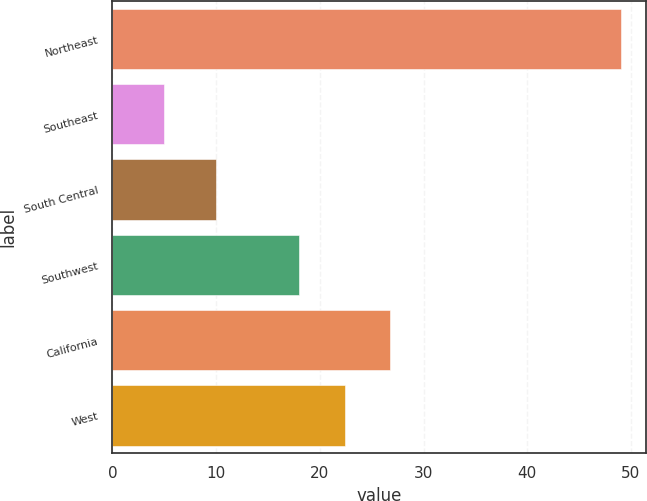Convert chart. <chart><loc_0><loc_0><loc_500><loc_500><bar_chart><fcel>Northeast<fcel>Southeast<fcel>South Central<fcel>Southwest<fcel>California<fcel>West<nl><fcel>49<fcel>5<fcel>10<fcel>18<fcel>26.8<fcel>22.4<nl></chart> 